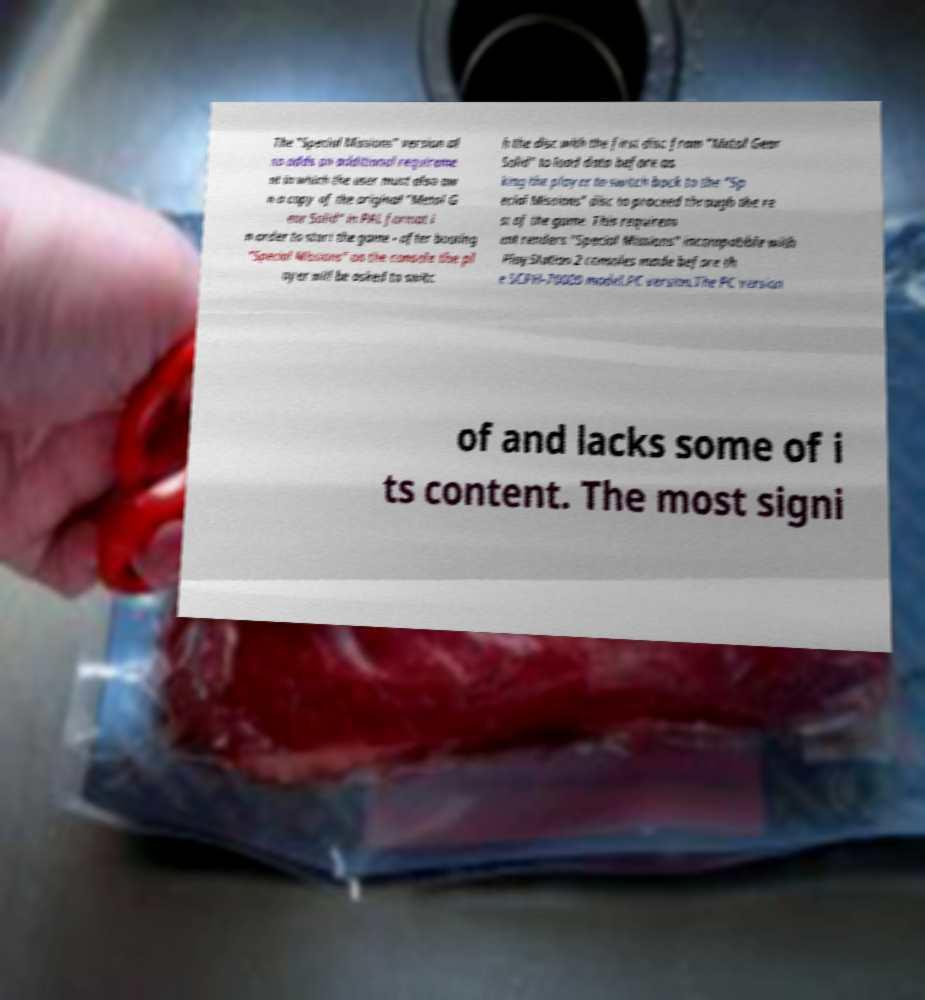Can you read and provide the text displayed in the image?This photo seems to have some interesting text. Can you extract and type it out for me? The "Special Missions" version al so adds an additional requireme nt in which the user must also ow n a copy of the original "Metal G ear Solid" in PAL format i n order to start the game - after booting "Special Missions" on the console the pl ayer will be asked to switc h the disc with the first disc from "Metal Gear Solid" to load data before as king the player to switch back to the "Sp ecial Missions" disc to proceed through the re st of the game. This requirem ent renders "Special Missions" incompatible with PlayStation 2 consoles made before th e SCPH-70000 model.PC version.The PC version of and lacks some of i ts content. The most signi 